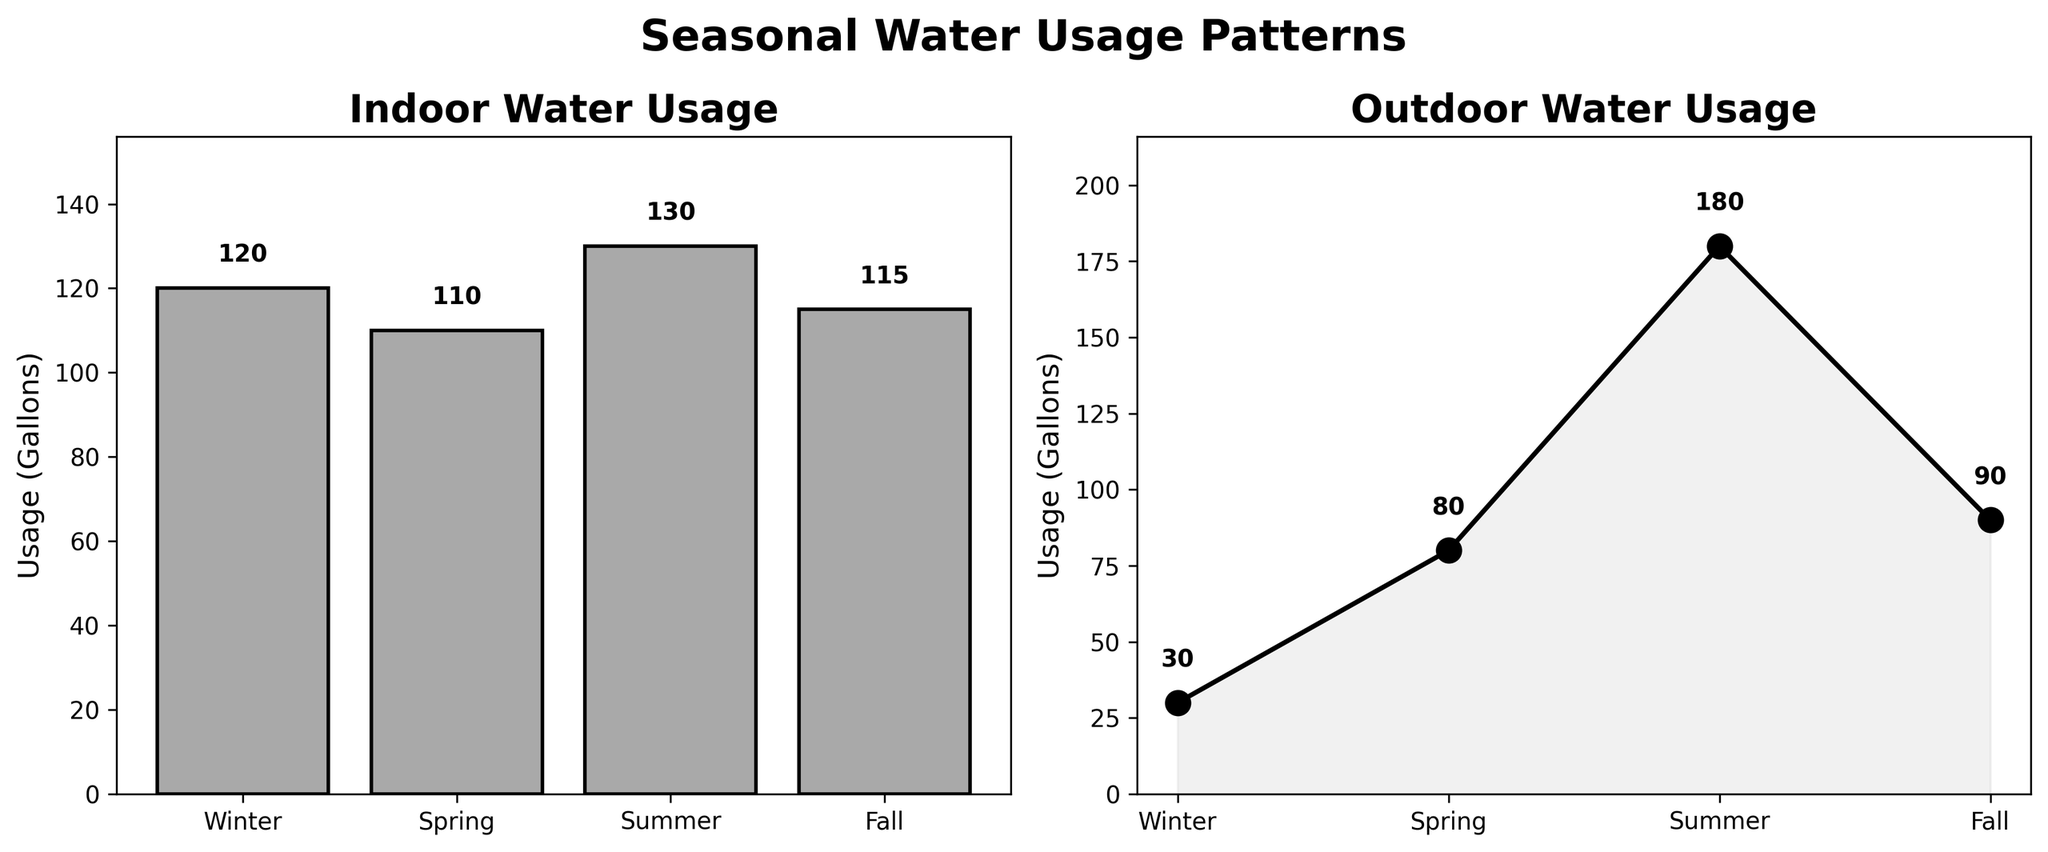How many seasons are plotted? The x-axis has season labels, and there are four visible data points in each subplot. The seasons are Winter, Spring, Summer, and Fall.
Answer: Four What's the title of the plot on the left? The title of the left subplot is explicitly stated at the top of the figure.
Answer: Indoor Water Usage Which season has the highest indoor water usage? By examining the height of the bars in the left subplot, the bar for Summer is the tallest, indicating the highest usage.
Answer: Summer Compare the indoor water usage of Winter and Spring. Which is greater? The height of the bar for Winter (120 gallons) is higher than that of Spring (110 gallons) in the left subplot.
Answer: Winter What is the difference in outdoor water usage between Summer and Fall? Summer's outdoor usage is 180 gallons, while Fall's is 90 gallons. Subtracting Fall's usage from Summer's gives 180 - 90 = 90 gallons.
Answer: 90 gallons What is the average indoor water usage across all seasons? Sum the indoor usages: 120 (Winter) + 110 (Spring) + 130 (Summer) + 115 (Fall) = 475 gallons. Dividing by 4 seasons gives an average of 475 / 4 = 118.75 gallons.
Answer: 118.75 gallons During which season is the outdoor water usage closest to 100 gallons? By looking at the plotted values, Fall has an outdoor water usage of 90 gallons which is closest to 100 gallons.
Answer: Fall What is the trend of outdoor water usage across the seasons? The outdoor water usage starts low in Winter at 30 gallons, increases in Spring to 80 gallons, peaks in Summer at 180 gallons, and then decreases in Fall to 90 gallons. Therefore, the trend indicates a significant rise during Summer and fall afterward.
Answer: Peaks in Summer 